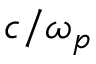<formula> <loc_0><loc_0><loc_500><loc_500>c / \omega _ { p }</formula> 